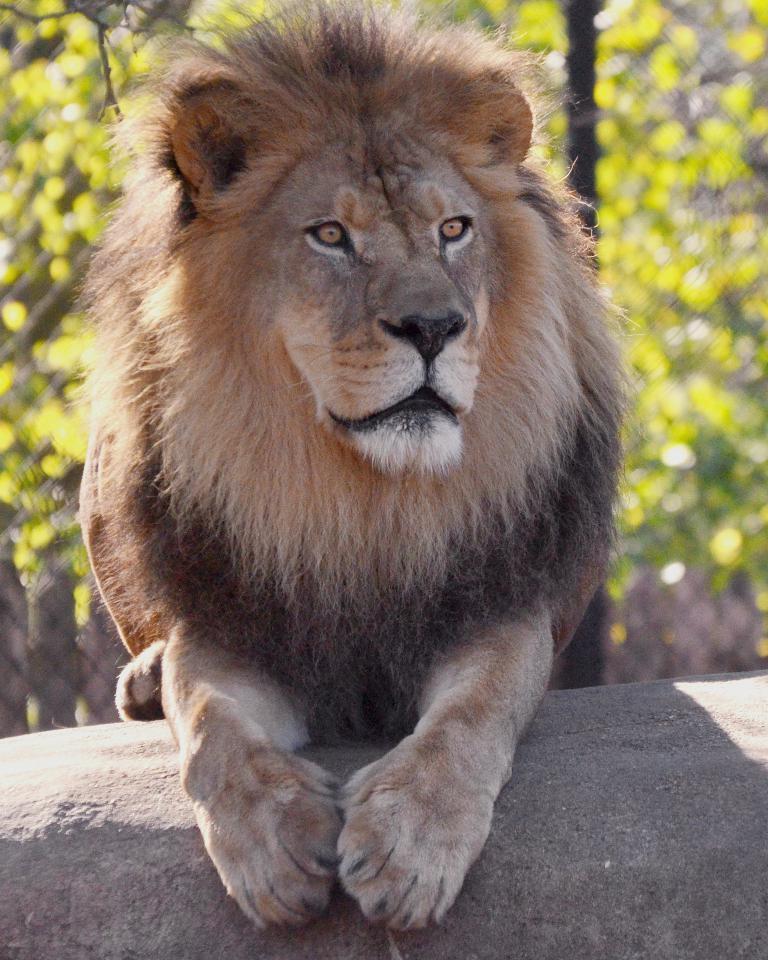Can you describe this image briefly? In this image we can see lion, behind trees are there. 